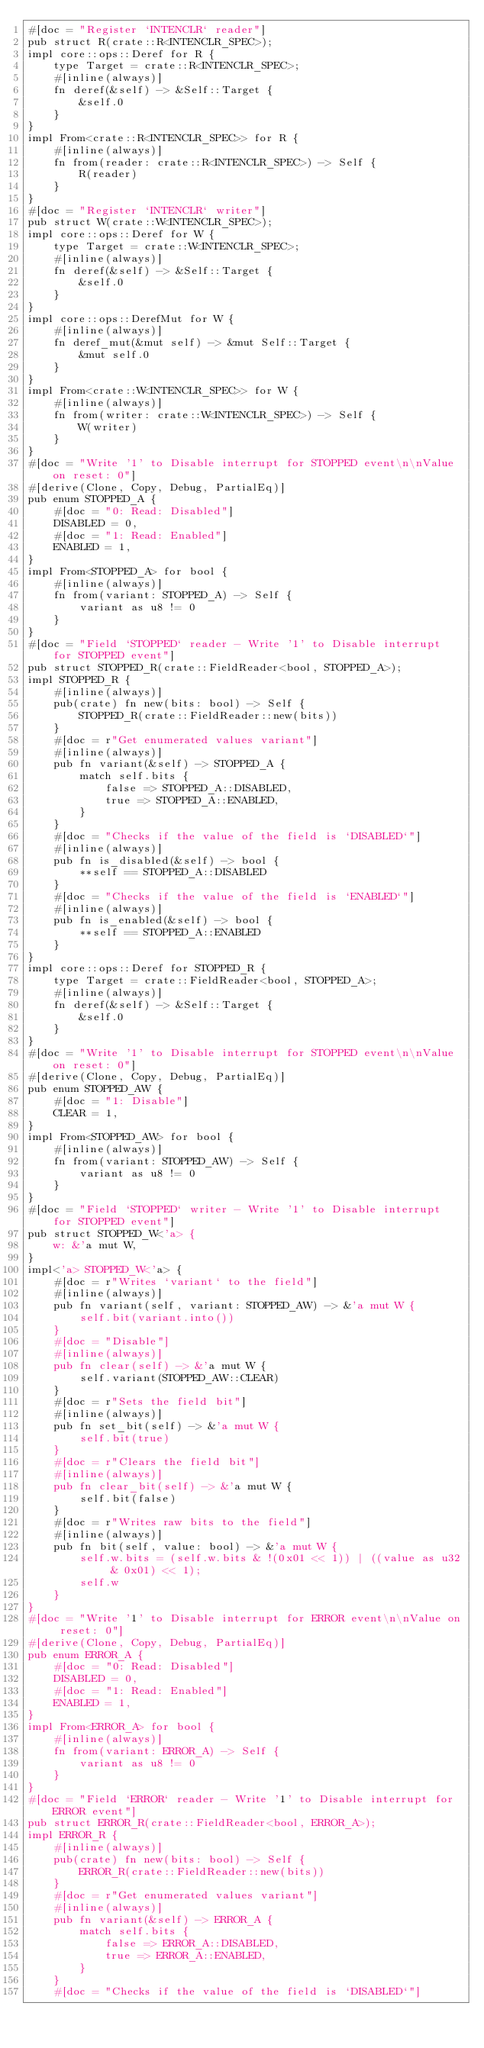<code> <loc_0><loc_0><loc_500><loc_500><_Rust_>#[doc = "Register `INTENCLR` reader"]
pub struct R(crate::R<INTENCLR_SPEC>);
impl core::ops::Deref for R {
    type Target = crate::R<INTENCLR_SPEC>;
    #[inline(always)]
    fn deref(&self) -> &Self::Target {
        &self.0
    }
}
impl From<crate::R<INTENCLR_SPEC>> for R {
    #[inline(always)]
    fn from(reader: crate::R<INTENCLR_SPEC>) -> Self {
        R(reader)
    }
}
#[doc = "Register `INTENCLR` writer"]
pub struct W(crate::W<INTENCLR_SPEC>);
impl core::ops::Deref for W {
    type Target = crate::W<INTENCLR_SPEC>;
    #[inline(always)]
    fn deref(&self) -> &Self::Target {
        &self.0
    }
}
impl core::ops::DerefMut for W {
    #[inline(always)]
    fn deref_mut(&mut self) -> &mut Self::Target {
        &mut self.0
    }
}
impl From<crate::W<INTENCLR_SPEC>> for W {
    #[inline(always)]
    fn from(writer: crate::W<INTENCLR_SPEC>) -> Self {
        W(writer)
    }
}
#[doc = "Write '1' to Disable interrupt for STOPPED event\n\nValue on reset: 0"]
#[derive(Clone, Copy, Debug, PartialEq)]
pub enum STOPPED_A {
    #[doc = "0: Read: Disabled"]
    DISABLED = 0,
    #[doc = "1: Read: Enabled"]
    ENABLED = 1,
}
impl From<STOPPED_A> for bool {
    #[inline(always)]
    fn from(variant: STOPPED_A) -> Self {
        variant as u8 != 0
    }
}
#[doc = "Field `STOPPED` reader - Write '1' to Disable interrupt for STOPPED event"]
pub struct STOPPED_R(crate::FieldReader<bool, STOPPED_A>);
impl STOPPED_R {
    #[inline(always)]
    pub(crate) fn new(bits: bool) -> Self {
        STOPPED_R(crate::FieldReader::new(bits))
    }
    #[doc = r"Get enumerated values variant"]
    #[inline(always)]
    pub fn variant(&self) -> STOPPED_A {
        match self.bits {
            false => STOPPED_A::DISABLED,
            true => STOPPED_A::ENABLED,
        }
    }
    #[doc = "Checks if the value of the field is `DISABLED`"]
    #[inline(always)]
    pub fn is_disabled(&self) -> bool {
        **self == STOPPED_A::DISABLED
    }
    #[doc = "Checks if the value of the field is `ENABLED`"]
    #[inline(always)]
    pub fn is_enabled(&self) -> bool {
        **self == STOPPED_A::ENABLED
    }
}
impl core::ops::Deref for STOPPED_R {
    type Target = crate::FieldReader<bool, STOPPED_A>;
    #[inline(always)]
    fn deref(&self) -> &Self::Target {
        &self.0
    }
}
#[doc = "Write '1' to Disable interrupt for STOPPED event\n\nValue on reset: 0"]
#[derive(Clone, Copy, Debug, PartialEq)]
pub enum STOPPED_AW {
    #[doc = "1: Disable"]
    CLEAR = 1,
}
impl From<STOPPED_AW> for bool {
    #[inline(always)]
    fn from(variant: STOPPED_AW) -> Self {
        variant as u8 != 0
    }
}
#[doc = "Field `STOPPED` writer - Write '1' to Disable interrupt for STOPPED event"]
pub struct STOPPED_W<'a> {
    w: &'a mut W,
}
impl<'a> STOPPED_W<'a> {
    #[doc = r"Writes `variant` to the field"]
    #[inline(always)]
    pub fn variant(self, variant: STOPPED_AW) -> &'a mut W {
        self.bit(variant.into())
    }
    #[doc = "Disable"]
    #[inline(always)]
    pub fn clear(self) -> &'a mut W {
        self.variant(STOPPED_AW::CLEAR)
    }
    #[doc = r"Sets the field bit"]
    #[inline(always)]
    pub fn set_bit(self) -> &'a mut W {
        self.bit(true)
    }
    #[doc = r"Clears the field bit"]
    #[inline(always)]
    pub fn clear_bit(self) -> &'a mut W {
        self.bit(false)
    }
    #[doc = r"Writes raw bits to the field"]
    #[inline(always)]
    pub fn bit(self, value: bool) -> &'a mut W {
        self.w.bits = (self.w.bits & !(0x01 << 1)) | ((value as u32 & 0x01) << 1);
        self.w
    }
}
#[doc = "Write '1' to Disable interrupt for ERROR event\n\nValue on reset: 0"]
#[derive(Clone, Copy, Debug, PartialEq)]
pub enum ERROR_A {
    #[doc = "0: Read: Disabled"]
    DISABLED = 0,
    #[doc = "1: Read: Enabled"]
    ENABLED = 1,
}
impl From<ERROR_A> for bool {
    #[inline(always)]
    fn from(variant: ERROR_A) -> Self {
        variant as u8 != 0
    }
}
#[doc = "Field `ERROR` reader - Write '1' to Disable interrupt for ERROR event"]
pub struct ERROR_R(crate::FieldReader<bool, ERROR_A>);
impl ERROR_R {
    #[inline(always)]
    pub(crate) fn new(bits: bool) -> Self {
        ERROR_R(crate::FieldReader::new(bits))
    }
    #[doc = r"Get enumerated values variant"]
    #[inline(always)]
    pub fn variant(&self) -> ERROR_A {
        match self.bits {
            false => ERROR_A::DISABLED,
            true => ERROR_A::ENABLED,
        }
    }
    #[doc = "Checks if the value of the field is `DISABLED`"]</code> 